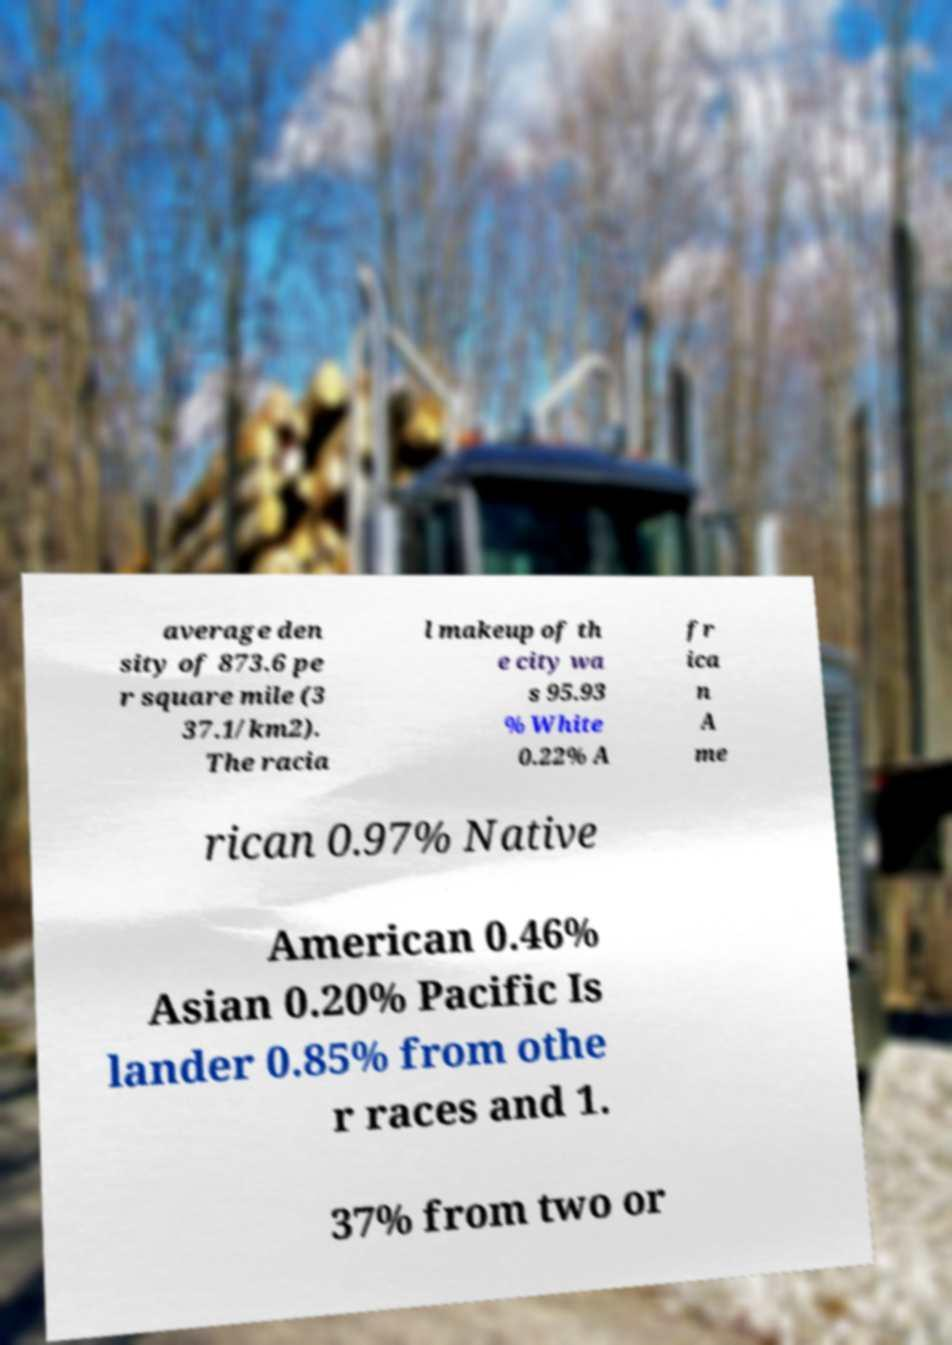Can you accurately transcribe the text from the provided image for me? average den sity of 873.6 pe r square mile (3 37.1/km2). The racia l makeup of th e city wa s 95.93 % White 0.22% A fr ica n A me rican 0.97% Native American 0.46% Asian 0.20% Pacific Is lander 0.85% from othe r races and 1. 37% from two or 